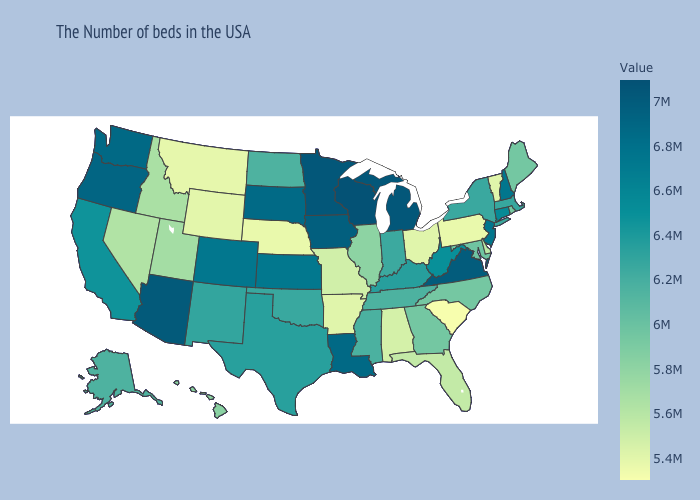Does South Carolina have the lowest value in the USA?
Concise answer only. Yes. Does Wyoming have the highest value in the West?
Write a very short answer. No. Which states have the lowest value in the Northeast?
Quick response, please. Pennsylvania. Among the states that border Delaware , does New Jersey have the highest value?
Answer briefly. Yes. 